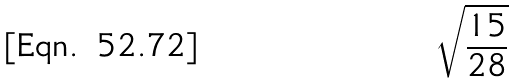Convert formula to latex. <formula><loc_0><loc_0><loc_500><loc_500>\sqrt { \frac { 1 5 } { 2 8 } }</formula> 